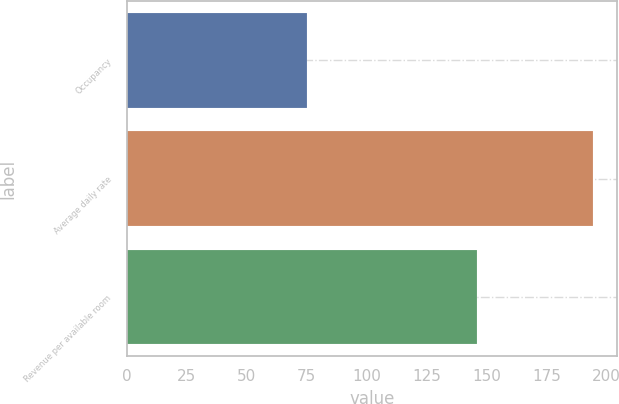Convert chart. <chart><loc_0><loc_0><loc_500><loc_500><bar_chart><fcel>Occupancy<fcel>Average daily rate<fcel>Revenue per available room<nl><fcel>75.1<fcel>194.52<fcel>146.15<nl></chart> 